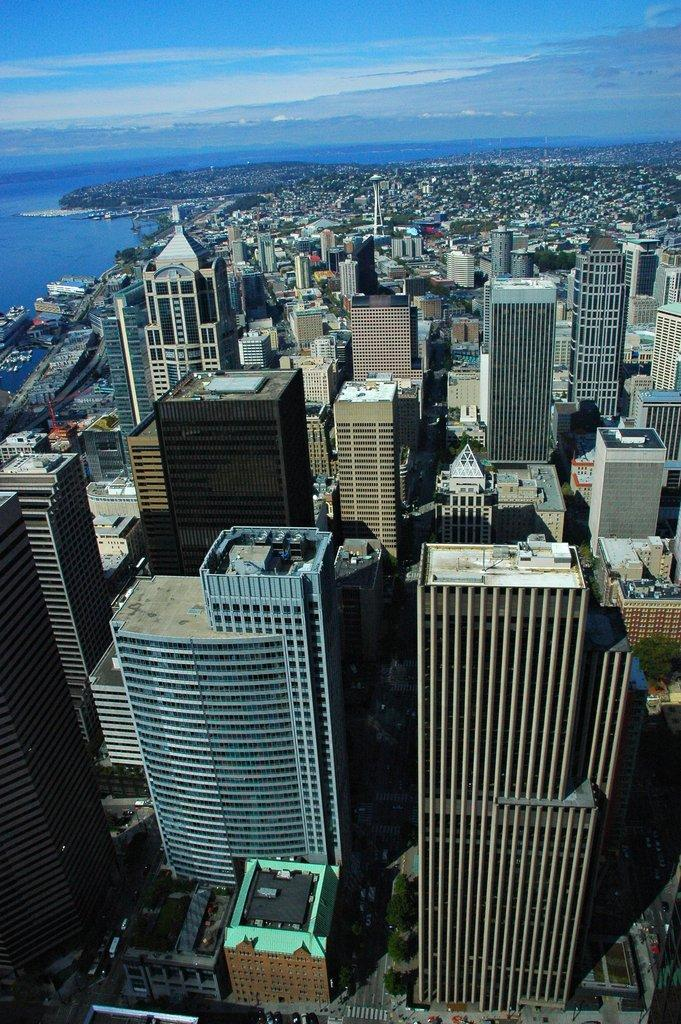What type of view is shown in the image? The image is an aerial view. What can be seen in the center of the image? There are many buildings in the center of the image. What natural feature is on the left side of the image? There is a sea on the left side of the image. What is visible at the top of the image? The sky is visible at the top of the image. Can you see a wren perched on the sea in the image? There is no wren present in the image, and the wren is not perched on the sea. What type of clam is visible in the image? There are no clams present in the image. 